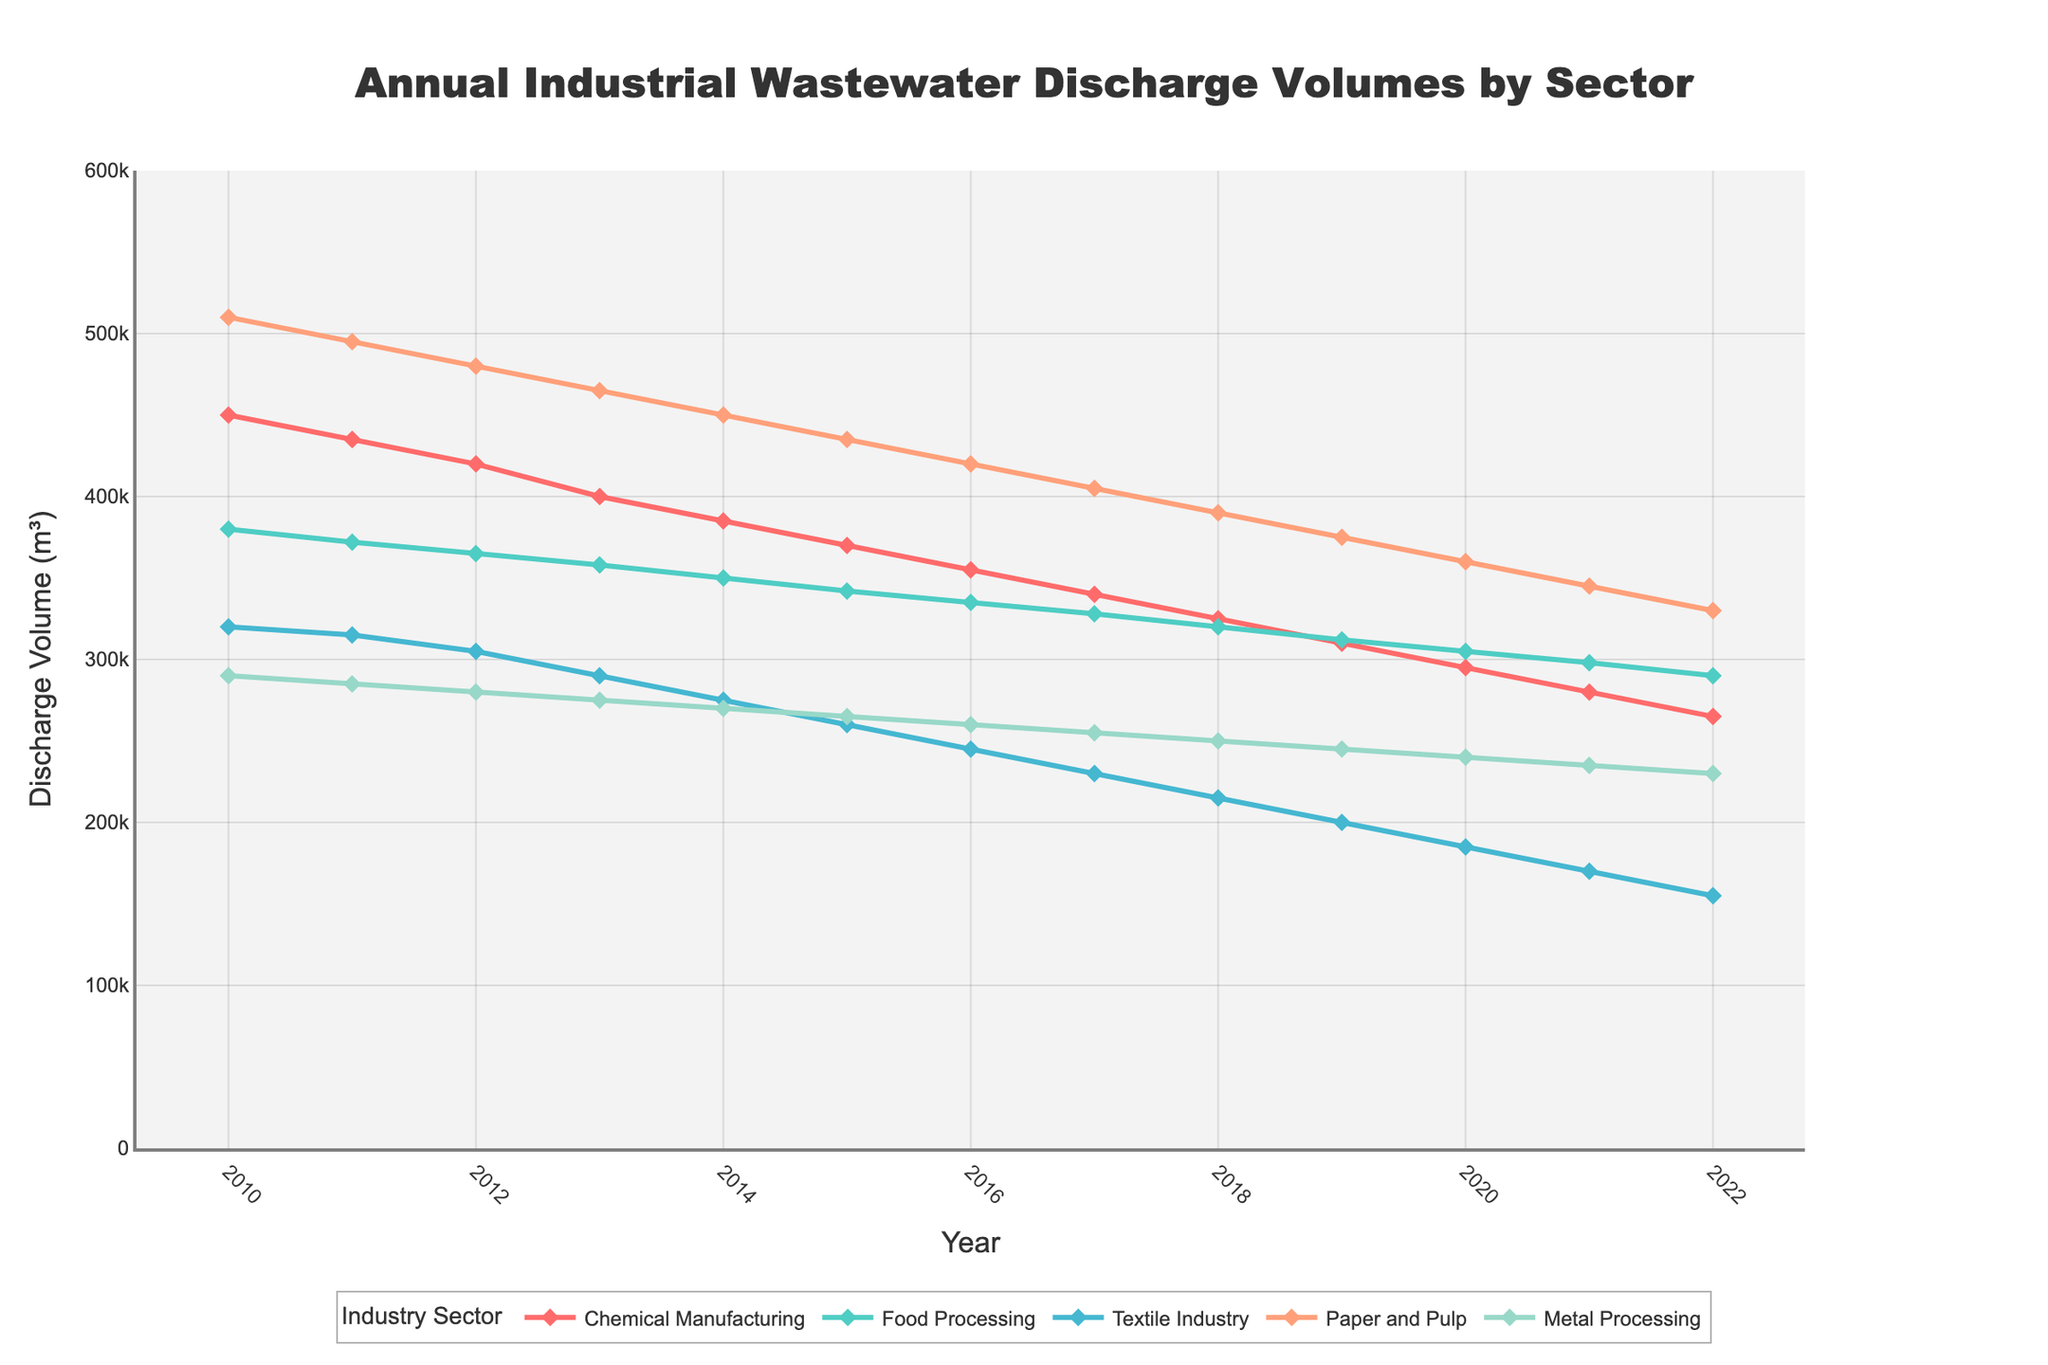What's the overall trend in annual wastewater discharge volumes for the Chemical Manufacturing sector from 2010 to 2022? To identify the trend, observe the line corresponding to the Chemical Manufacturing sector from 2010 to 2022. The discharge volume decreases each year progressively from 450,000 m³ in 2010 to 265,000 m³ in 2022, indicating a downward trend.
Answer: Downward trend Which industry showed the most significant reduction in discharge volumes over the given period? To find the industry with the most significant reduction, compare the starting and ending discharge volumes for each industry. The Textile Industry goes from 320,000 m³ in 2010 to 155,000 m³ in 2022, a reduction of 165,000 m³, which is the largest decrease.
Answer: Textile Industry In which year did the Paper and Pulp industry discharge fall below 400,000 m³? Look at the discharge volumes for the Paper and Pulp industry in each year. In 2017, the discharge volume was 405,000 m³, while in 2018, it dropped to 390,000 m³. Therefore, the year it fell below 400,000 m³ was 2018.
Answer: 2018 How does the discharge volume of the Food Processing sector in 2020 compare to its volume in 2015? To compare, locate the discharge volumes for the Food Processing sector in 2020 and 2015. In 2020, the volume is 305,000 m³, and in 2015, it is 342,000 m³. The volume in 2020 is lower than in 2015.
Answer: Lower in 2020 What is the total reduction in discharge volumes for the Metal Processing sector from 2010 to 2022? Calculate the difference between the discharge volumes in 2010 and 2022 for the Metal Processing sector. The volume decreases from 290,000 m³ in 2010 to 230,000 m³ in 2022. The total reduction is 290,000 m³ - 230,000 m³ = 60,000 m³.
Answer: 60,000 m³ Which sector had the smallest change in discharge volumes between 2010 and 2022? Determine the change for each sector by subtracting the 2022 volume from the 2010 volume. Compare these changes: 
- Chemical Manufacturing: 450,000 - 265,000 = 185,000 m³
- Food Processing: 380,000 - 290,000 = 90,000 m³
- Textile Industry: 320,000 - 155,000 = 165,000 m³
- Paper and Pulp: 510,000 - 330,000 = 180,000 m³
- Metal Processing: 290,000 - 230,000 = 60,000 m³
The Metal Processing sector shows the smallest change at 60,000 m³.
Answer: Metal Processing By how much did the discharge volume for the Food Processing sector decrease from 2011 to 2017? Subtract the 2017 discharge volume from the 2011 volume for the Food Processing sector. The volumes are 372,000 m³ in 2011 and 328,000 m³ in 2017. The decrease is 372,000 m³ - 328,000 m³ = 44,000 m³.
Answer: 44,000 m³ Which sector had consistently lower discharge volumes than the Paper and Pulp sector throughout the given period? Compare the discharge volumes of each sector with that of the Paper and Pulp sector for each year from 2010 to 2022. The Metal Processing sector had consistently lower discharge volumes each year compared to the Paper and Pulp sector.
Answer: Metal Processing Which sector's wastewater discharge volumes showed the largest fluctuation between years? Analyze the yearly change for each sector by noting the differences between consecutive years. The Paper and Pulp sector shows significant year-to-year changes, such as from 2010 to 2011 (510,000 m³ to 495,000 m³) and other subsequent years. Overall, this sector shows the largest fluctuations.
Answer: Paper and Pulp 